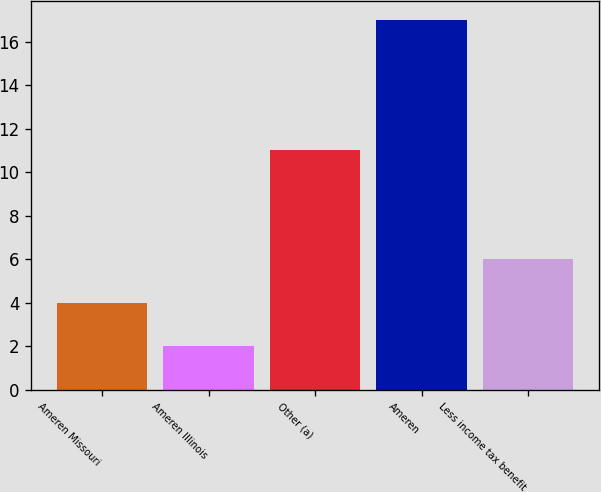<chart> <loc_0><loc_0><loc_500><loc_500><bar_chart><fcel>Ameren Missouri<fcel>Ameren Illinois<fcel>Other (a)<fcel>Ameren<fcel>Less income tax benefit<nl><fcel>4<fcel>2<fcel>11<fcel>17<fcel>6<nl></chart> 